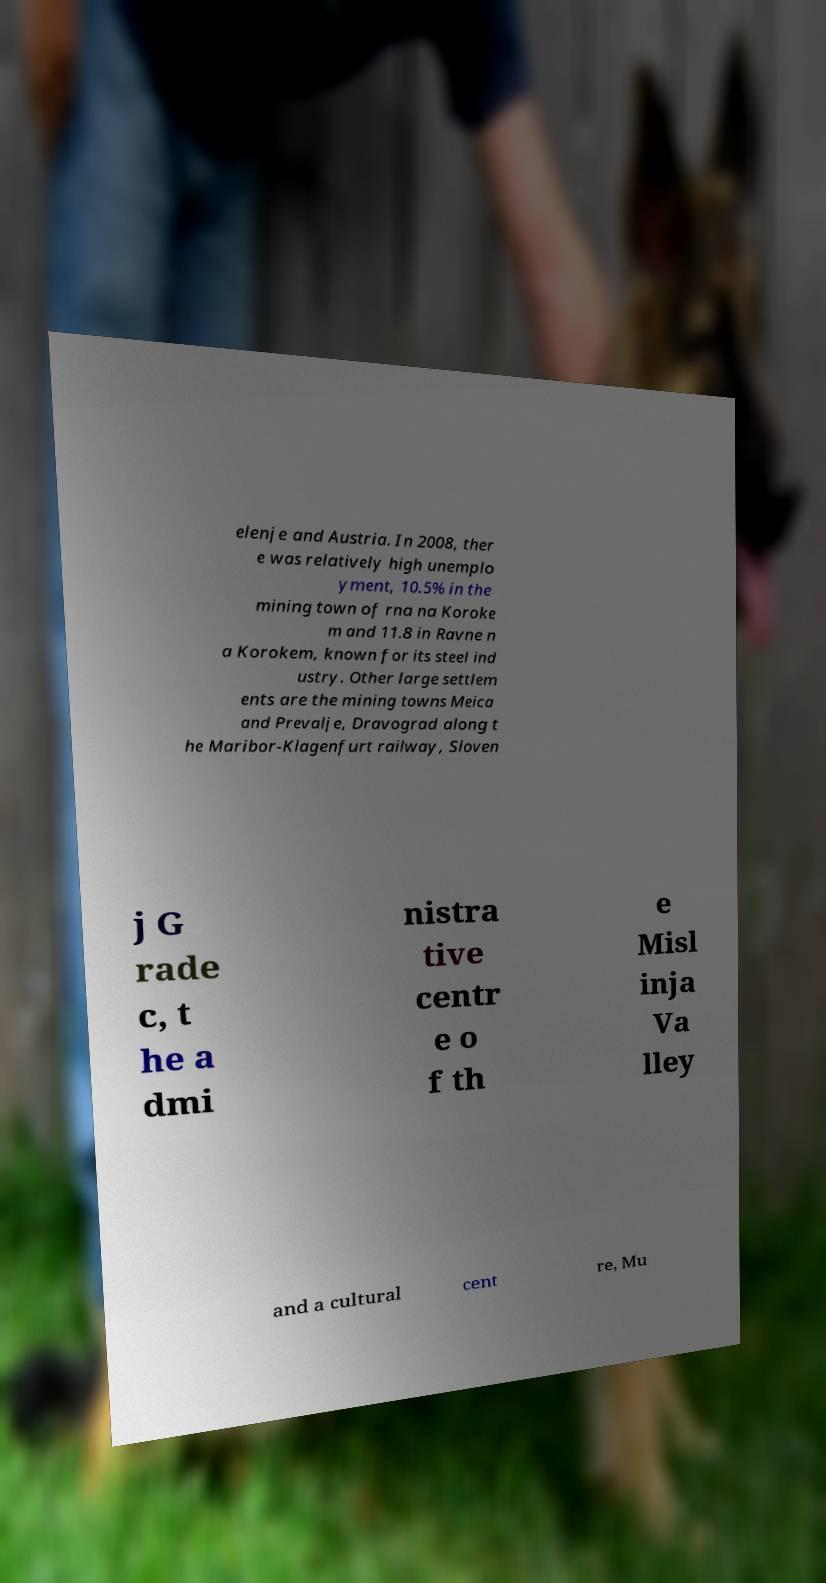Please identify and transcribe the text found in this image. elenje and Austria. In 2008, ther e was relatively high unemplo yment, 10.5% in the mining town of rna na Koroke m and 11.8 in Ravne n a Korokem, known for its steel ind ustry. Other large settlem ents are the mining towns Meica and Prevalje, Dravograd along t he Maribor-Klagenfurt railway, Sloven j G rade c, t he a dmi nistra tive centr e o f th e Misl inja Va lley and a cultural cent re, Mu 